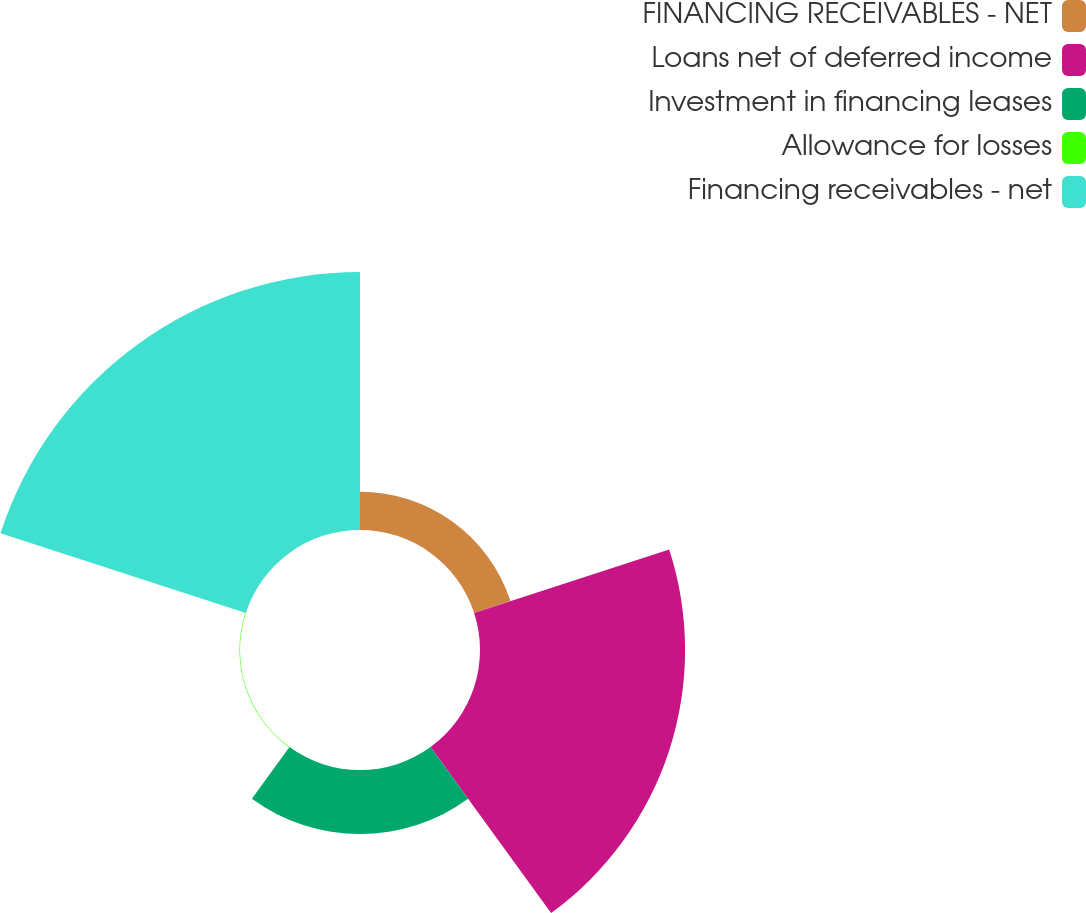Convert chart to OTSL. <chart><loc_0><loc_0><loc_500><loc_500><pie_chart><fcel>FINANCING RECEIVABLES - NET<fcel>Loans net of deferred income<fcel>Investment in financing leases<fcel>Allowance for losses<fcel>Financing receivables - net<nl><fcel>6.75%<fcel>36.25%<fcel>11.3%<fcel>0.09%<fcel>45.6%<nl></chart> 